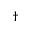<formula> <loc_0><loc_0><loc_500><loc_500>^ { \dagger }</formula> 